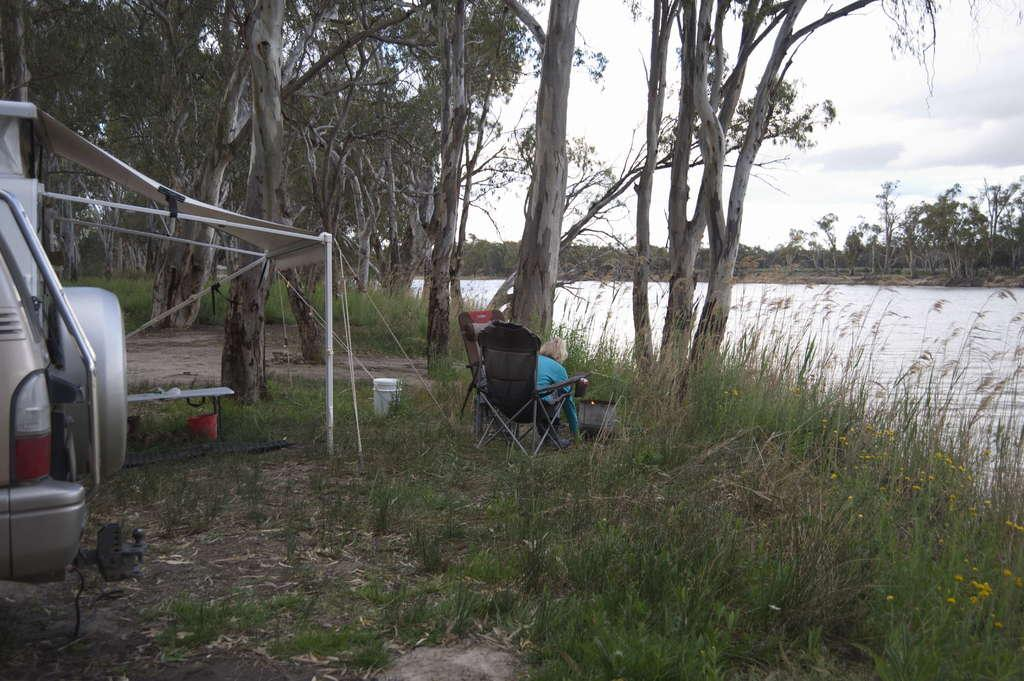What is the main subject of the image? There is a vehicle in the image. What type of environment is depicted in the image? The image features grass, trees, and water, suggesting a natural setting. Can you describe the woman in the image? There is a woman sitting on a chair in the image. What can be seen in the sky in the image? The sky is visible in the image. How does the boy use magic to make the vehicle fly in the image? There is no boy or magic present in the image; it features a vehicle, a woman sitting on a chair, and a natural setting. 